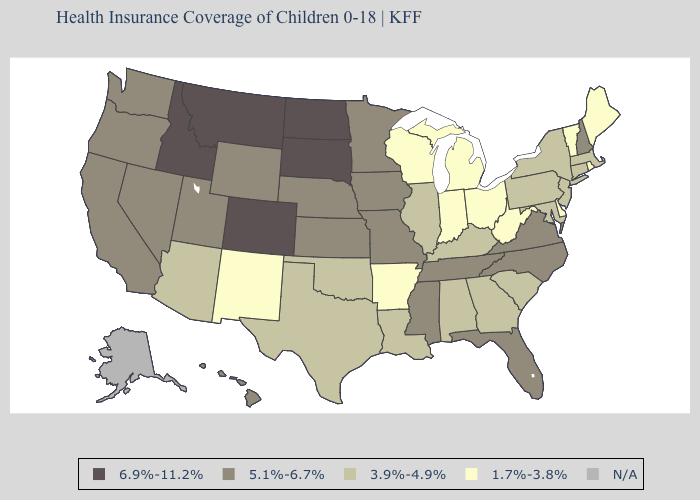Does Delaware have the lowest value in the USA?
Give a very brief answer. Yes. Name the states that have a value in the range 6.9%-11.2%?
Keep it brief. Colorado, Idaho, Montana, North Dakota, South Dakota. Which states have the lowest value in the South?
Keep it brief. Arkansas, Delaware, West Virginia. Among the states that border Illinois , which have the lowest value?
Give a very brief answer. Indiana, Wisconsin. Among the states that border Washington , does Idaho have the lowest value?
Be succinct. No. What is the value of Connecticut?
Keep it brief. 3.9%-4.9%. Does the first symbol in the legend represent the smallest category?
Write a very short answer. No. Name the states that have a value in the range 6.9%-11.2%?
Keep it brief. Colorado, Idaho, Montana, North Dakota, South Dakota. Name the states that have a value in the range 3.9%-4.9%?
Quick response, please. Alabama, Arizona, Connecticut, Georgia, Illinois, Kentucky, Louisiana, Maryland, Massachusetts, New Jersey, New York, Oklahoma, Pennsylvania, South Carolina, Texas. What is the highest value in states that border Maryland?
Keep it brief. 5.1%-6.7%. What is the value of Maine?
Be succinct. 1.7%-3.8%. 